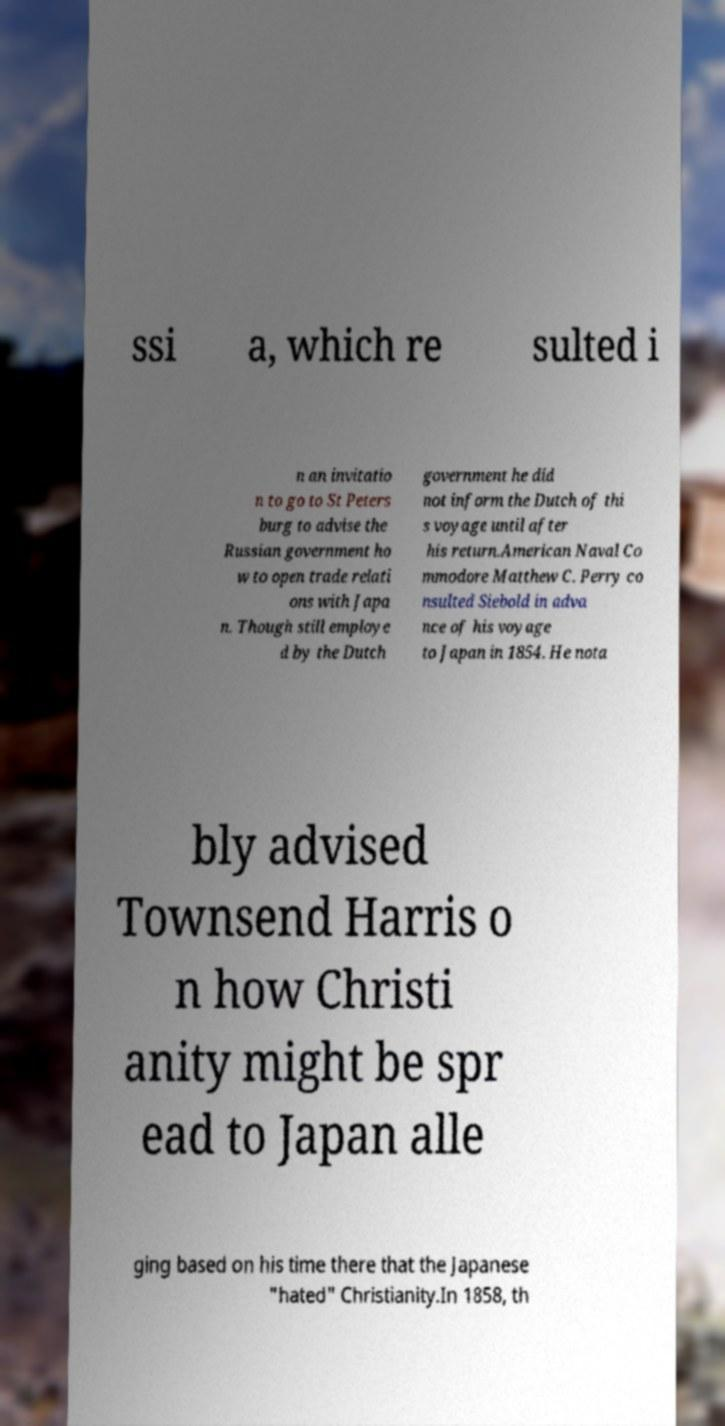Please read and relay the text visible in this image. What does it say? ssi a, which re sulted i n an invitatio n to go to St Peters burg to advise the Russian government ho w to open trade relati ons with Japa n. Though still employe d by the Dutch government he did not inform the Dutch of thi s voyage until after his return.American Naval Co mmodore Matthew C. Perry co nsulted Siebold in adva nce of his voyage to Japan in 1854. He nota bly advised Townsend Harris o n how Christi anity might be spr ead to Japan alle ging based on his time there that the Japanese "hated" Christianity.In 1858, th 